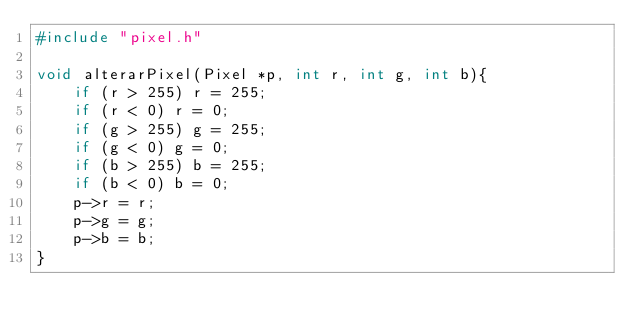Convert code to text. <code><loc_0><loc_0><loc_500><loc_500><_C_>#include "pixel.h"

void alterarPixel(Pixel *p, int r, int g, int b){
    if (r > 255) r = 255;
    if (r < 0) r = 0;
    if (g > 255) g = 255;
    if (g < 0) g = 0;
    if (b > 255) b = 255;
    if (b < 0) b = 0;
    p->r = r;
    p->g = g;
    p->b = b;
}</code> 